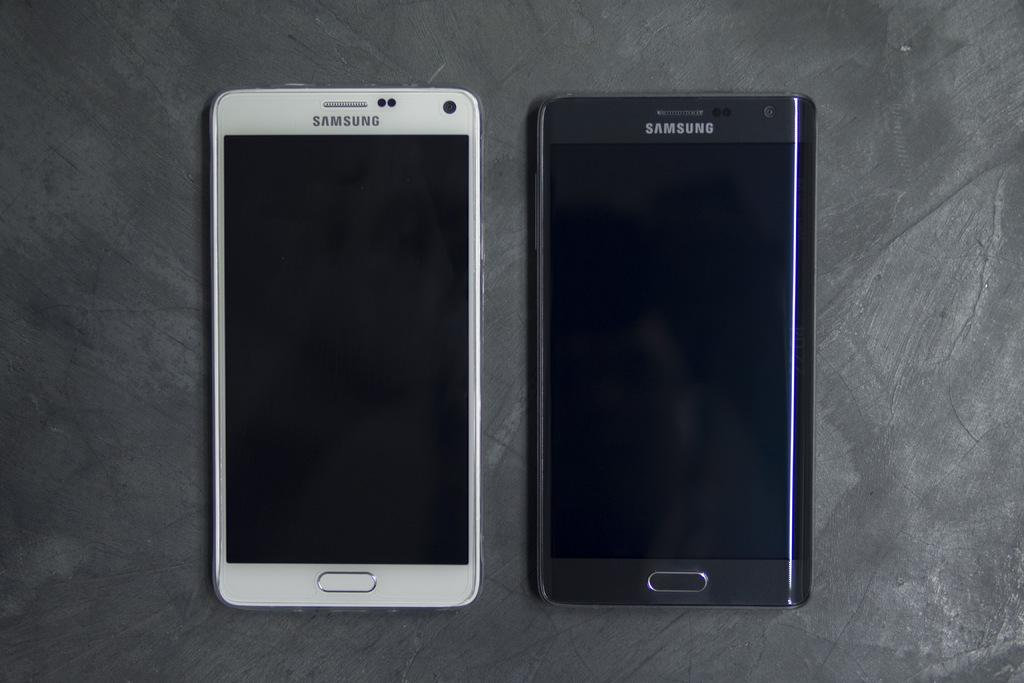<image>
Provide a brief description of the given image. A white Samsung brand smartphone beside a black Samsung smartphone on a table 